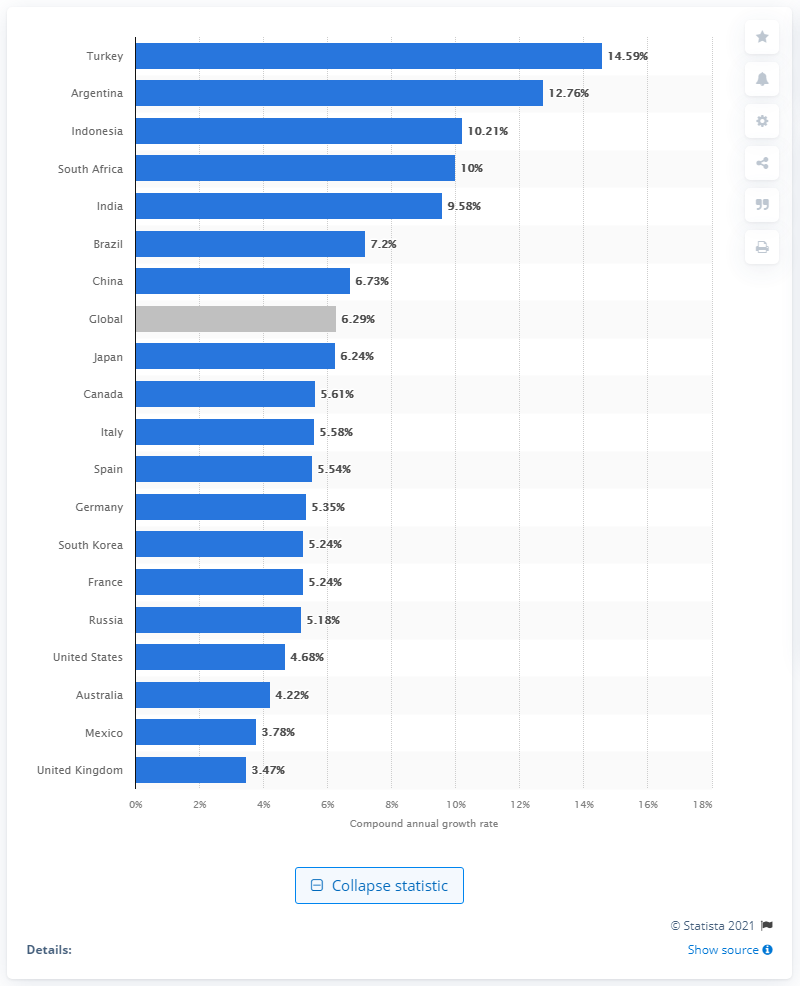Highlight a few significant elements in this photo. Turkey's retail e-commerce growth rate is 14.59%. The e-commerce growth rate in retail globally during the specified period was 6.29%. 